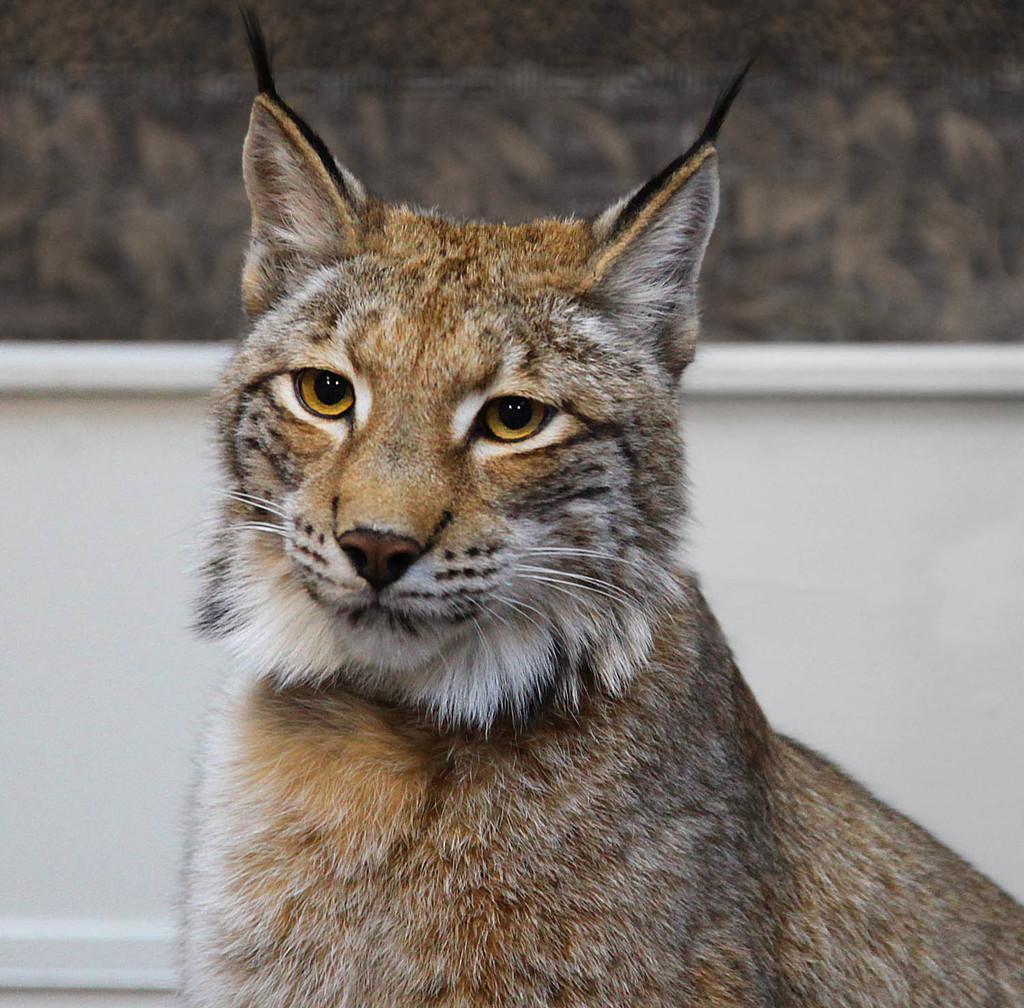Can you describe this image briefly? In the picture we can see a wild cat with fur to it and in the background, we can see a wall which is white in color. 